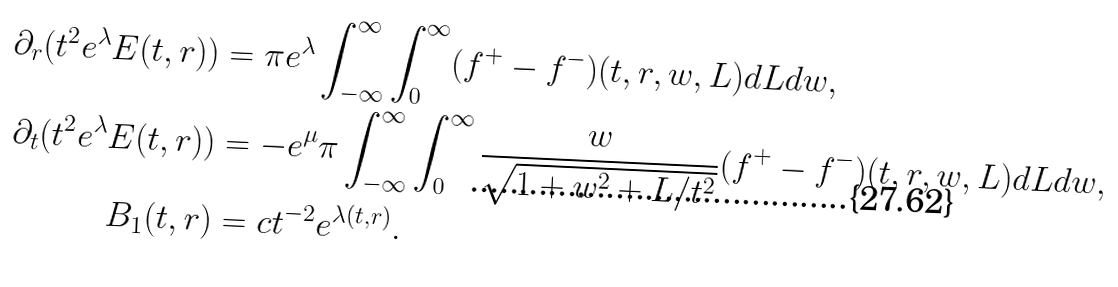<formula> <loc_0><loc_0><loc_500><loc_500>\partial _ { r } ( t ^ { 2 } e ^ { \lambda } E ( t , r ) ) & = \pi e ^ { \lambda } \int _ { - \infty } ^ { \infty } \int _ { 0 } ^ { \infty } ( f ^ { + } - f ^ { - } ) ( t , r , w , L ) d L d w , \\ \partial _ { t } ( t ^ { 2 } e ^ { \lambda } E ( t , r ) ) & = - e ^ { \mu } \pi \int _ { - \infty } ^ { \infty } \int _ { 0 } ^ { \infty } \frac { w } { \sqrt { 1 + w ^ { 2 } + L / t ^ { 2 } } } ( f ^ { + } - f ^ { - } ) ( t , r , w , L ) d L d w , \\ B _ { 1 } ( t , r ) & = c t ^ { - 2 } e ^ { \lambda ( t , r ) } .</formula> 